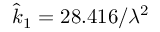Convert formula to latex. <formula><loc_0><loc_0><loc_500><loc_500>\hat { k } _ { 1 } = 2 8 . 4 1 6 / \lambda ^ { 2 }</formula> 